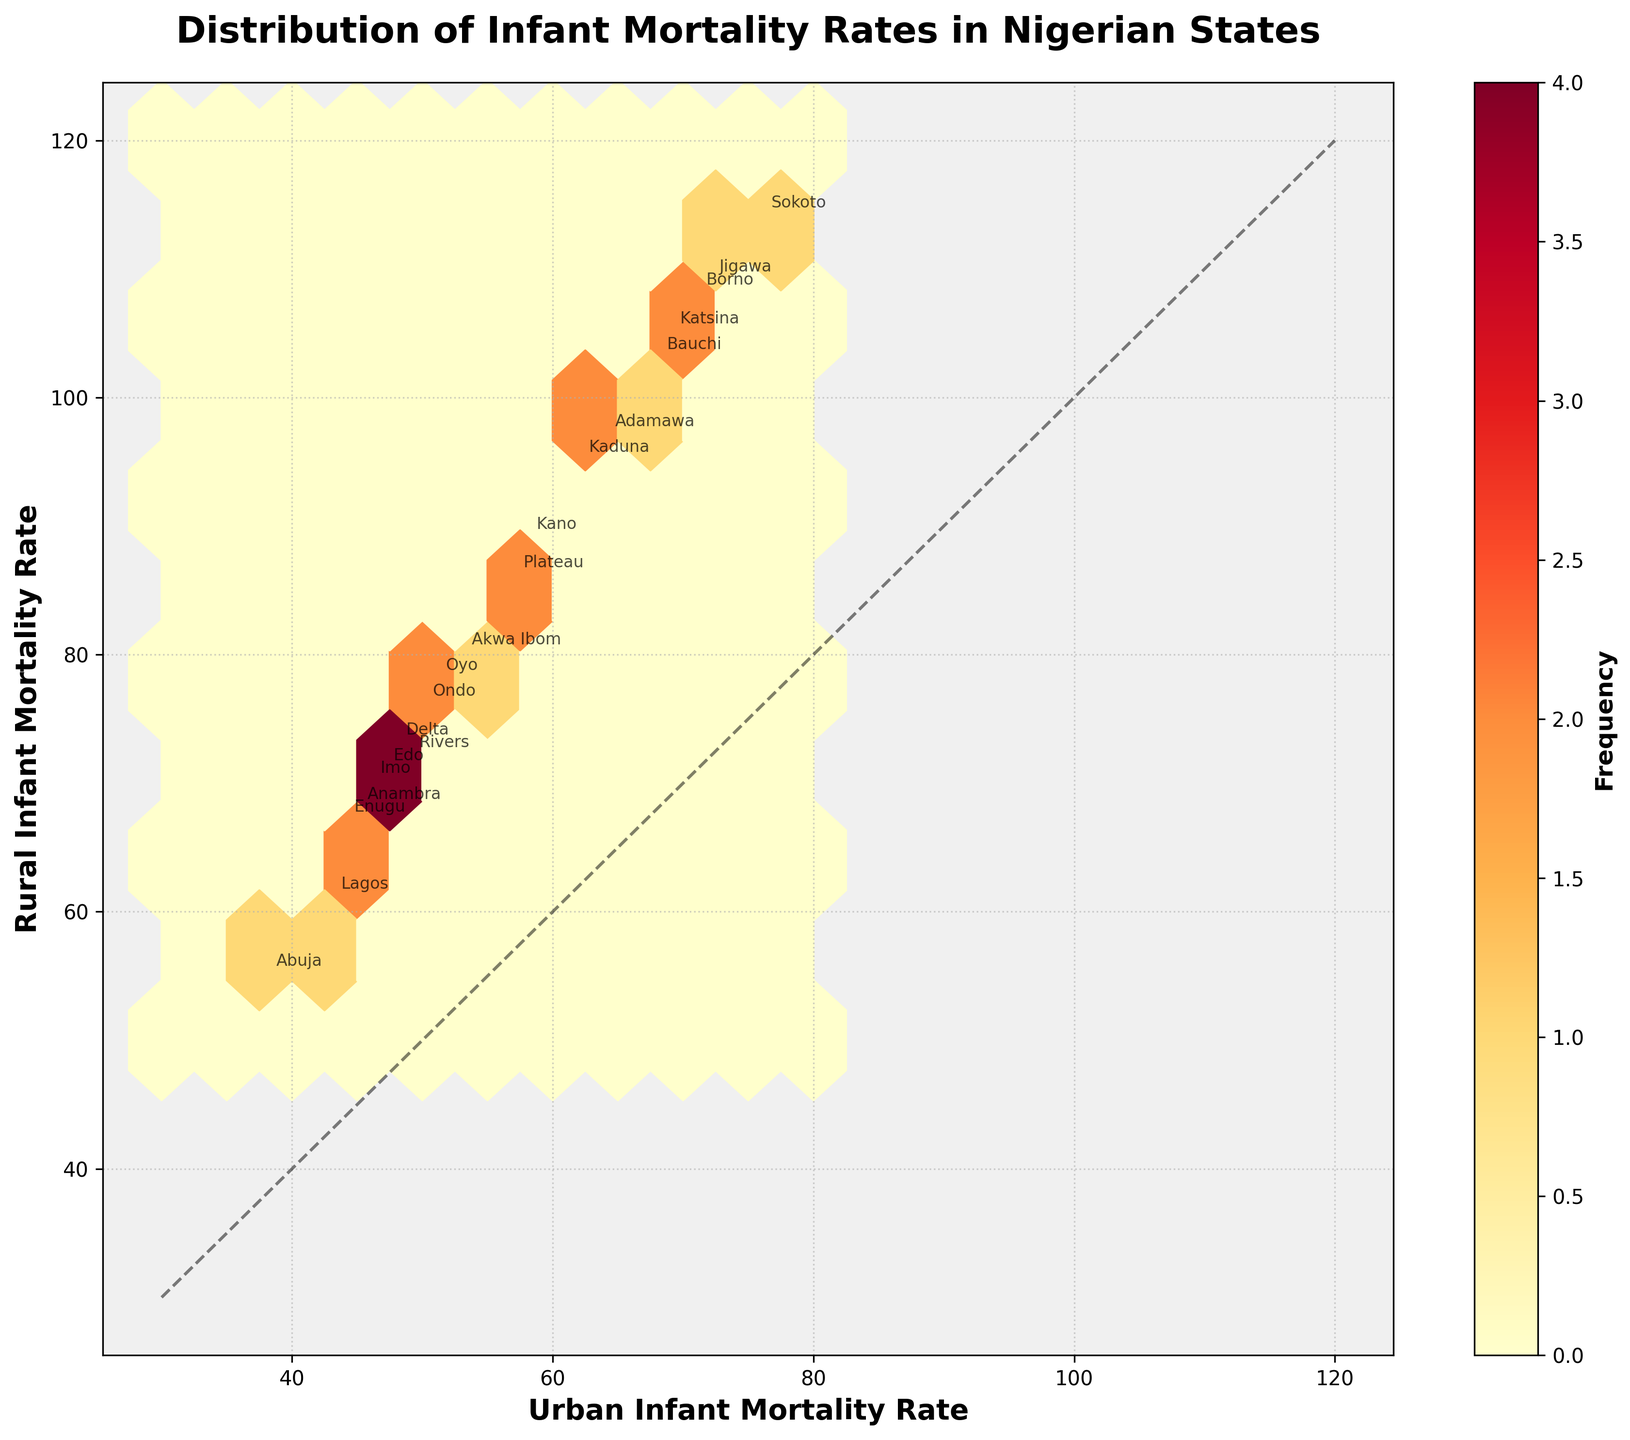What's the title of the hexbin plot? The title is displayed at the top of the plot and provides an overview of what the plot represents.
Answer: Distribution of Infant Mortality Rates in Nigerian States What do the x and y axes represent? The x and y axes are labeled with the type of data they represent.
Answer: Urban Infant Mortality Rate and Rural Infant Mortality Rate How many states have higher infant mortality rates in rural areas compared to urban areas? Count the states positioned above the diagonal line, which represents equal mortality rates in both areas.
Answer: 19 Which state has the highest rural Infant Mortality Rate (IMR)? Look for the data point with the highest value on the y-axis and identify its label.
Answer: Jigawa Which state shows the smallest difference between urban and rural IMR? Find the data point closest to the diagonal line and identify its label.
Answer: Abuja How many hexagonal bins are used on the plot? Check the number of hexagons in the grid. This can be inferred from the "gridsize" parameter used in the hexbin plot code.
Answer: 10 What is the color bar labeled? The label on the color bar indicates what the different colors represent in terms of data.
Answer: Frequency Is there any state with an equal urban and rural IMR? Check if any data point lies exactly on the diagonal line where urban and rural IMR are equal.
Answer: No Which state has the highest combined urban and rural IMR? Add the urban and rural IMR values for each state and identify the state with the highest sum.
Answer: Jigawa What is the color at the lower end of the frequency spectrum on the color bar? The color representing the lowest frequency value on the color bar can be identified by looking at the gradient scale.
Answer: Light Yellow 